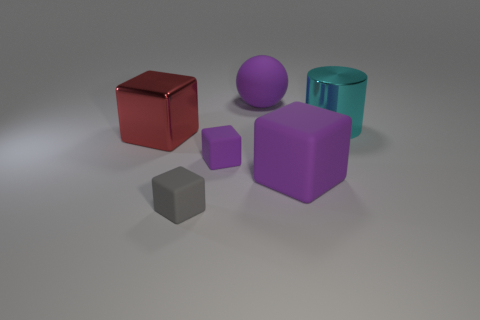Does the rubber sphere have the same size as the shiny thing behind the red shiny cube?
Your response must be concise. Yes. Is the number of large purple matte balls that are in front of the small gray matte cube less than the number of big rubber blocks?
Make the answer very short. Yes. What number of other big metallic cylinders have the same color as the cylinder?
Offer a terse response. 0. Are there fewer big purple cylinders than big cyan cylinders?
Provide a succinct answer. Yes. Do the large red thing and the small gray thing have the same material?
Provide a succinct answer. No. How many other things are the same size as the gray matte block?
Provide a succinct answer. 1. The metallic thing that is on the right side of the big object on the left side of the tiny purple block is what color?
Keep it short and to the point. Cyan. How many other things are there of the same shape as the small gray thing?
Provide a succinct answer. 3. Is there a large object made of the same material as the gray cube?
Provide a short and direct response. Yes. There is a purple object that is the same size as the sphere; what material is it?
Offer a very short reply. Rubber. 